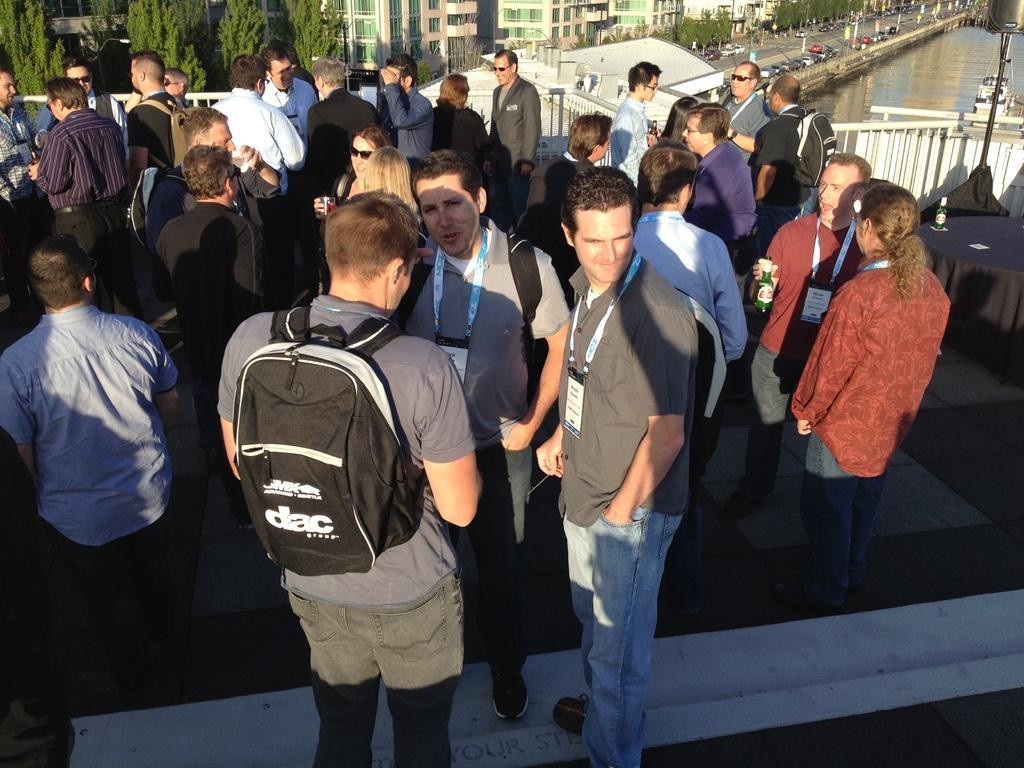Can you describe this image briefly? This picture describes about group of people they are all standing in the middle of the image a man is wearing a backpack, in the right side of the image a man is holding a bottle in his hands, in the background we can see couple of trees, buildings, vehicles and water. 